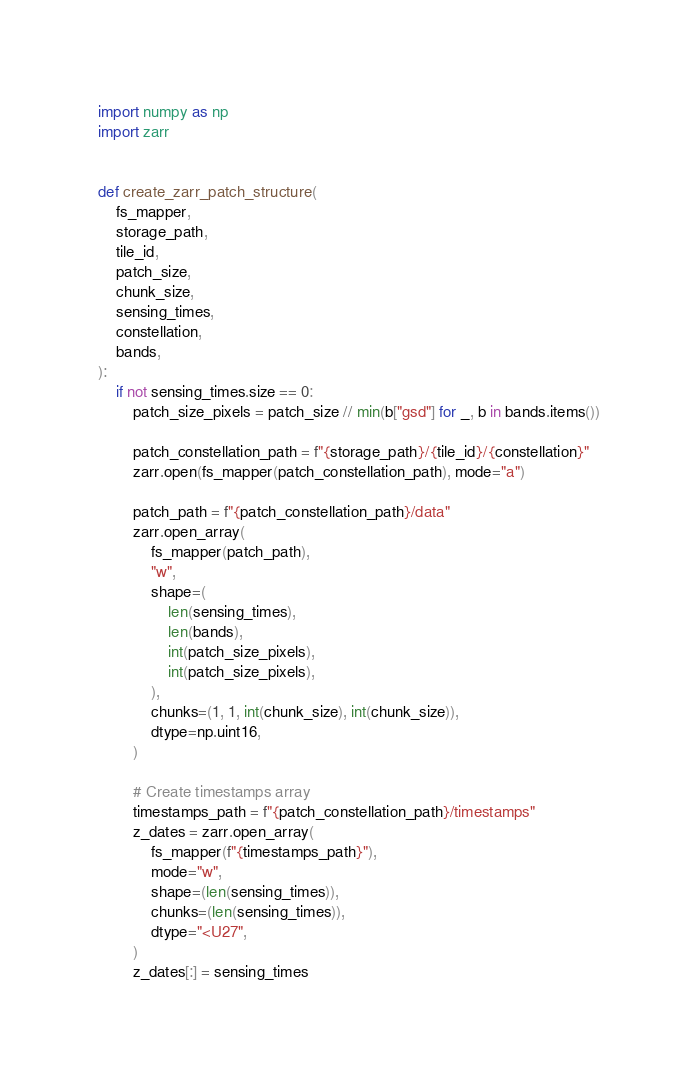<code> <loc_0><loc_0><loc_500><loc_500><_Python_>import numpy as np
import zarr


def create_zarr_patch_structure(
    fs_mapper,
    storage_path,
    tile_id,
    patch_size,
    chunk_size,
    sensing_times,
    constellation,
    bands,
):
    if not sensing_times.size == 0:
        patch_size_pixels = patch_size // min(b["gsd"] for _, b in bands.items())

        patch_constellation_path = f"{storage_path}/{tile_id}/{constellation}"
        zarr.open(fs_mapper(patch_constellation_path), mode="a")

        patch_path = f"{patch_constellation_path}/data"
        zarr.open_array(
            fs_mapper(patch_path),
            "w",
            shape=(
                len(sensing_times),
                len(bands),
                int(patch_size_pixels),
                int(patch_size_pixels),
            ),
            chunks=(1, 1, int(chunk_size), int(chunk_size)),
            dtype=np.uint16,
        )

        # Create timestamps array
        timestamps_path = f"{patch_constellation_path}/timestamps"
        z_dates = zarr.open_array(
            fs_mapper(f"{timestamps_path}"),
            mode="w",
            shape=(len(sensing_times)),
            chunks=(len(sensing_times)),
            dtype="<U27",
        )
        z_dates[:] = sensing_times
</code> 